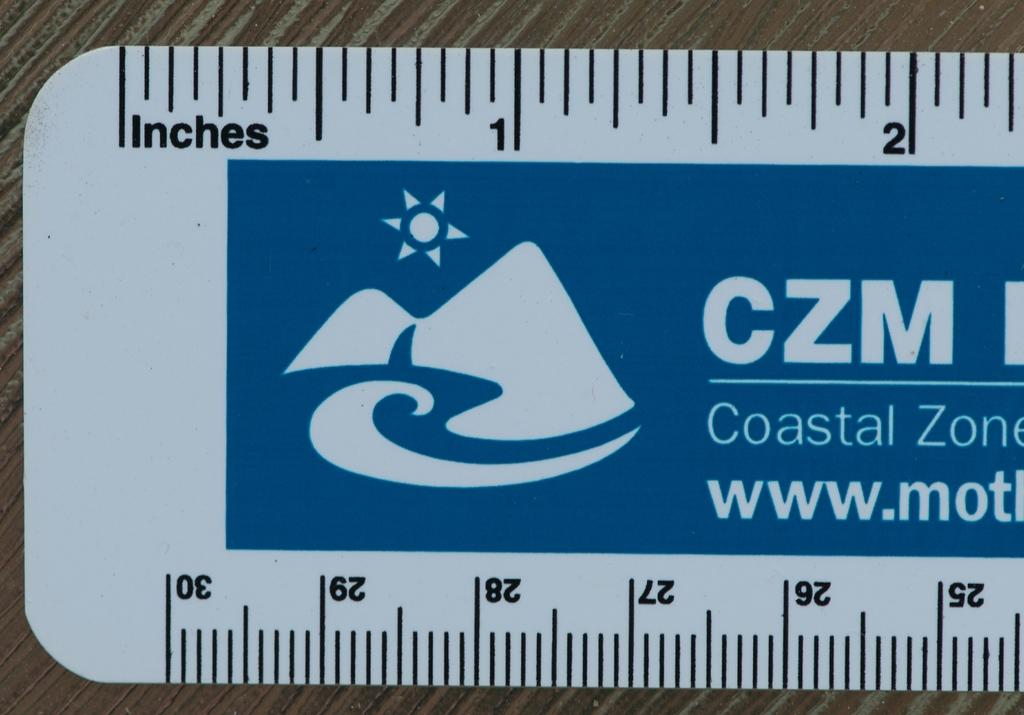<image>
Present a compact description of the photo's key features. A blue and white ruler with the words Coastal Zone printed on it. 